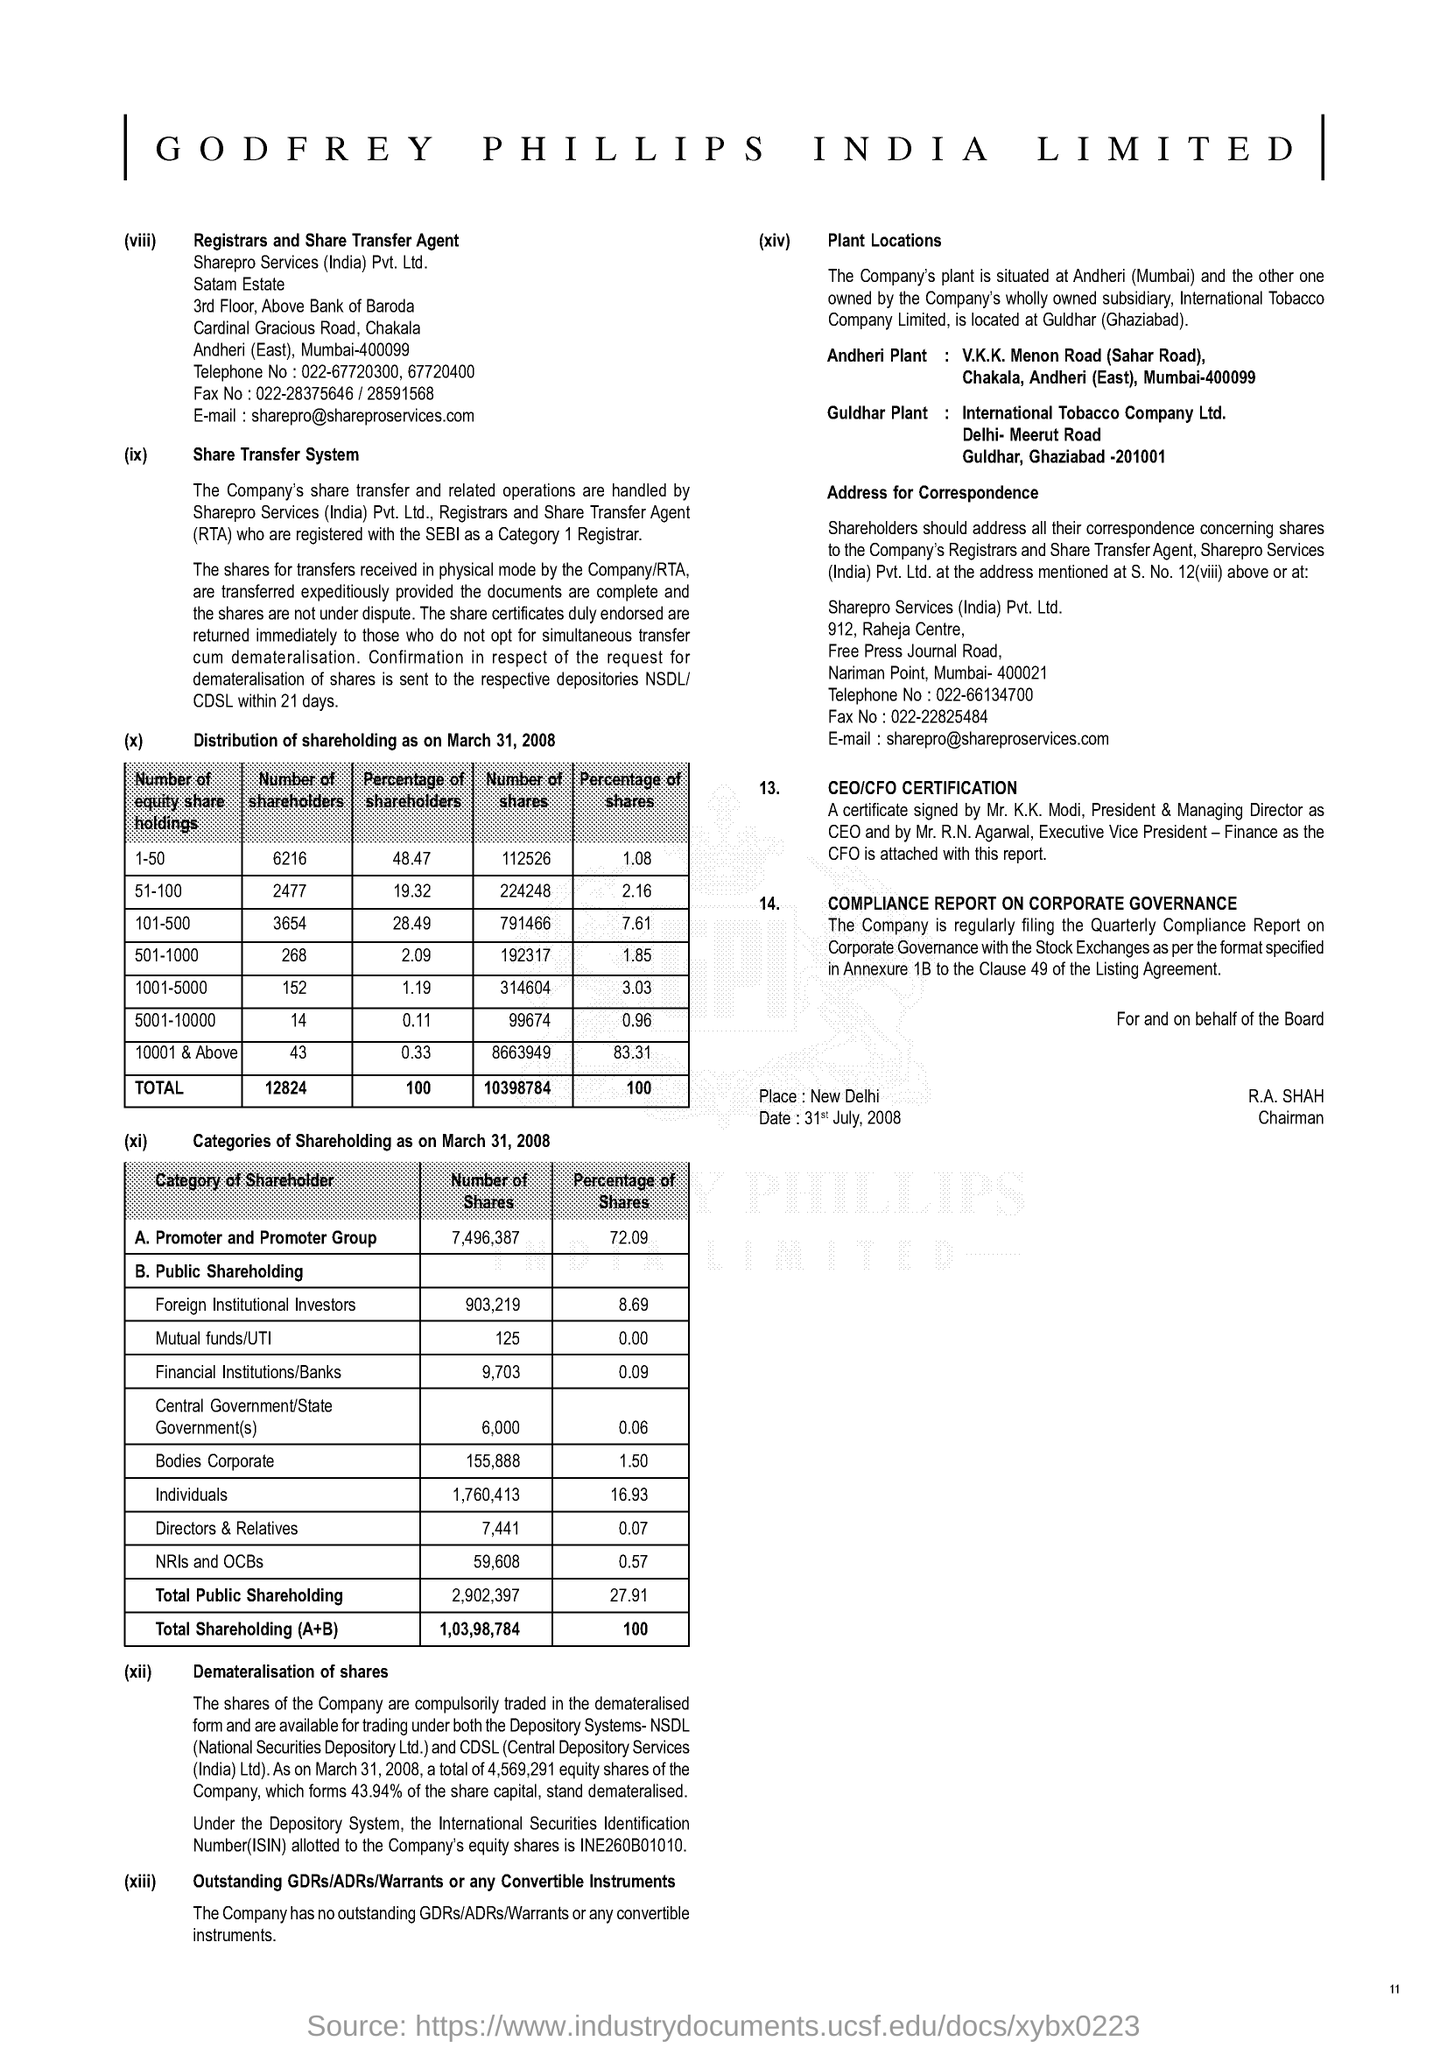What is the % of Shareholders between  51-100 ?
Offer a terse response. 19.32. What is the Fullform of ISIN ?
Offer a very short reply. International Securities Identification  Number. What is the Fullform of NSDL ?
Your answer should be compact. (National Securities Depository Ltd.). 